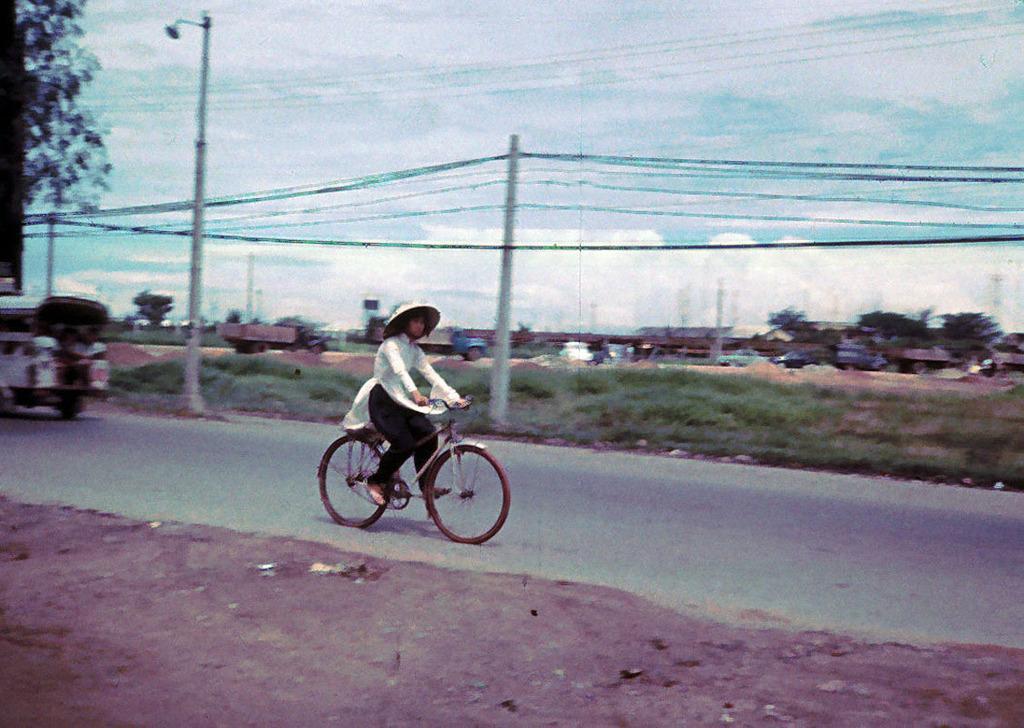How would you summarize this image in a sentence or two? In this picture we can see a person is riding bicycle on the road, in the background we can find few vehicles, poles and cables, and also we can see trees. 